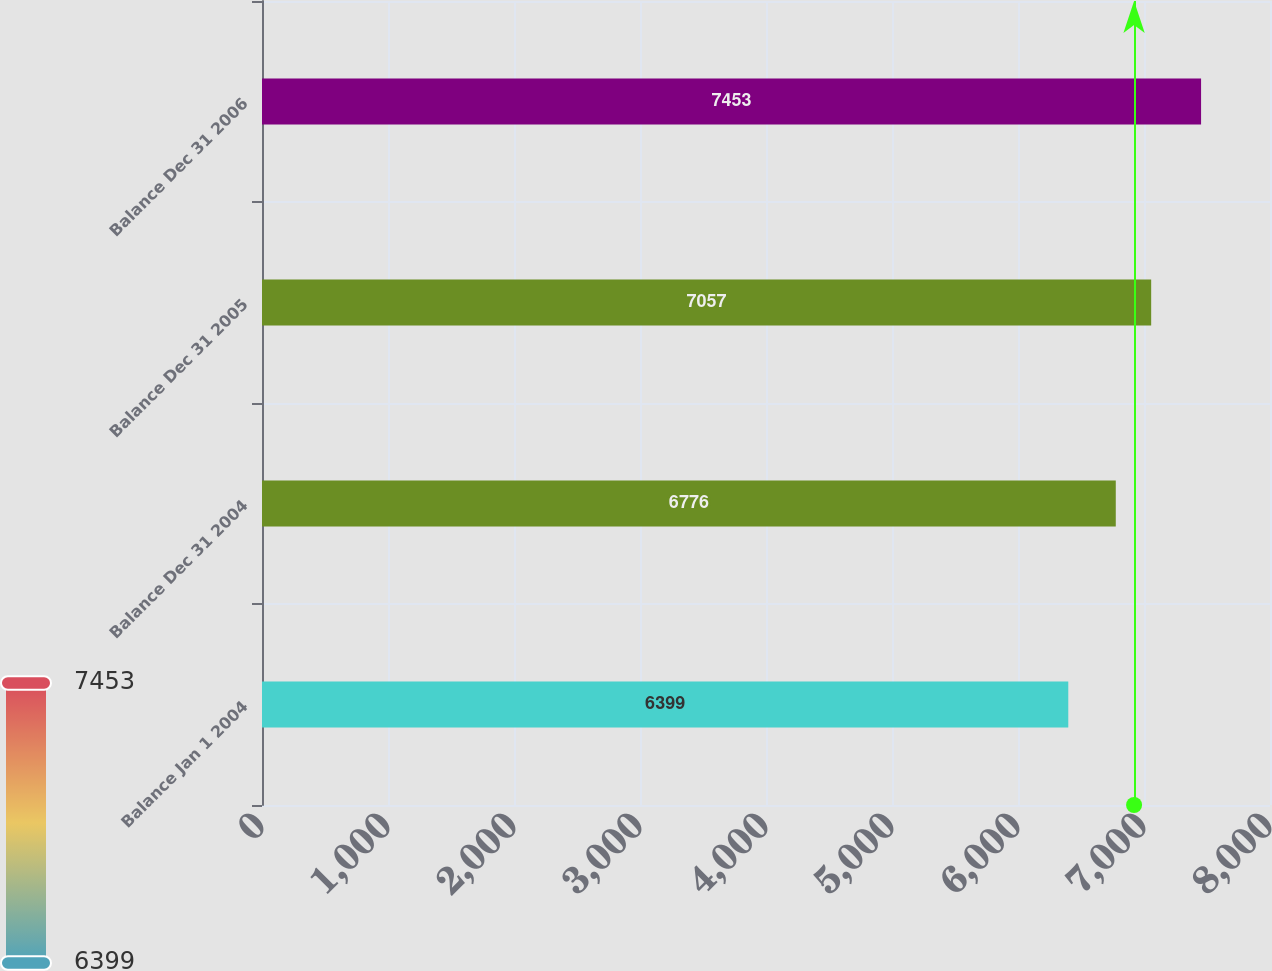<chart> <loc_0><loc_0><loc_500><loc_500><bar_chart><fcel>Balance Jan 1 2004<fcel>Balance Dec 31 2004<fcel>Balance Dec 31 2005<fcel>Balance Dec 31 2006<nl><fcel>6399<fcel>6776<fcel>7057<fcel>7453<nl></chart> 